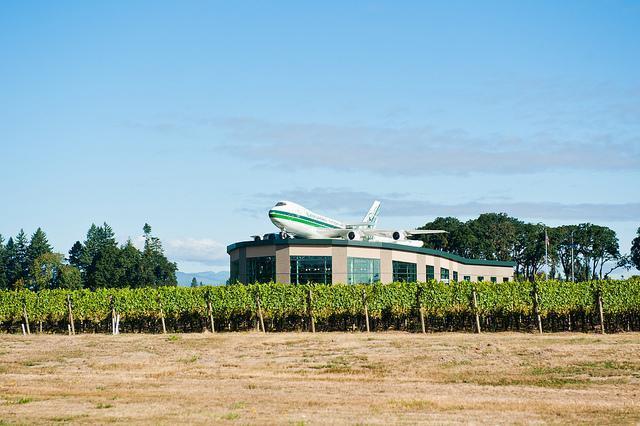How many buildings are in the picture?
Give a very brief answer. 1. How many people are facing away from the players?
Give a very brief answer. 0. 